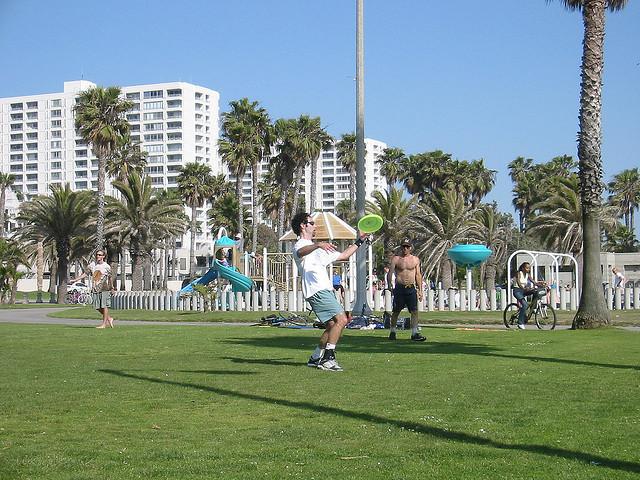If it's 3 pm in the scene, what direction is the Frisbee player facing?
Answer briefly. West. What number of palm trees line the park?
Quick response, please. 20. Who is riding a bicycle?
Write a very short answer. Girl. 